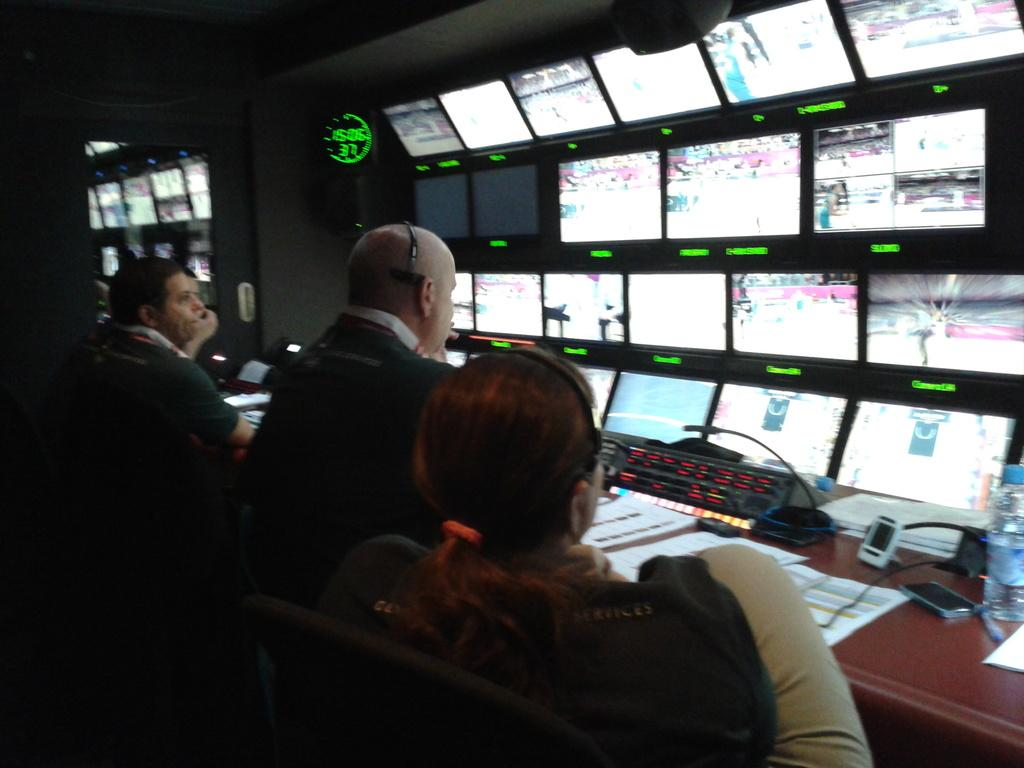Who or what can be seen in the image? There are people in the image. What objects are present in the image that people might sit on? There are chairs in the image. What items are on the table in the image? There are bottles, papers, and devices on the table. What type of surface is visible in the image that might be used for displaying information? There is a screen visible. What architectural feature can be seen in the image that might allow for natural light and a view of the outdoors? There is a glass door in the image. What disease is being treated in the image? There is no indication of any disease or medical treatment in the image. What is the primary interest of the people in the image? The image does not provide any information about the interests of the people. 